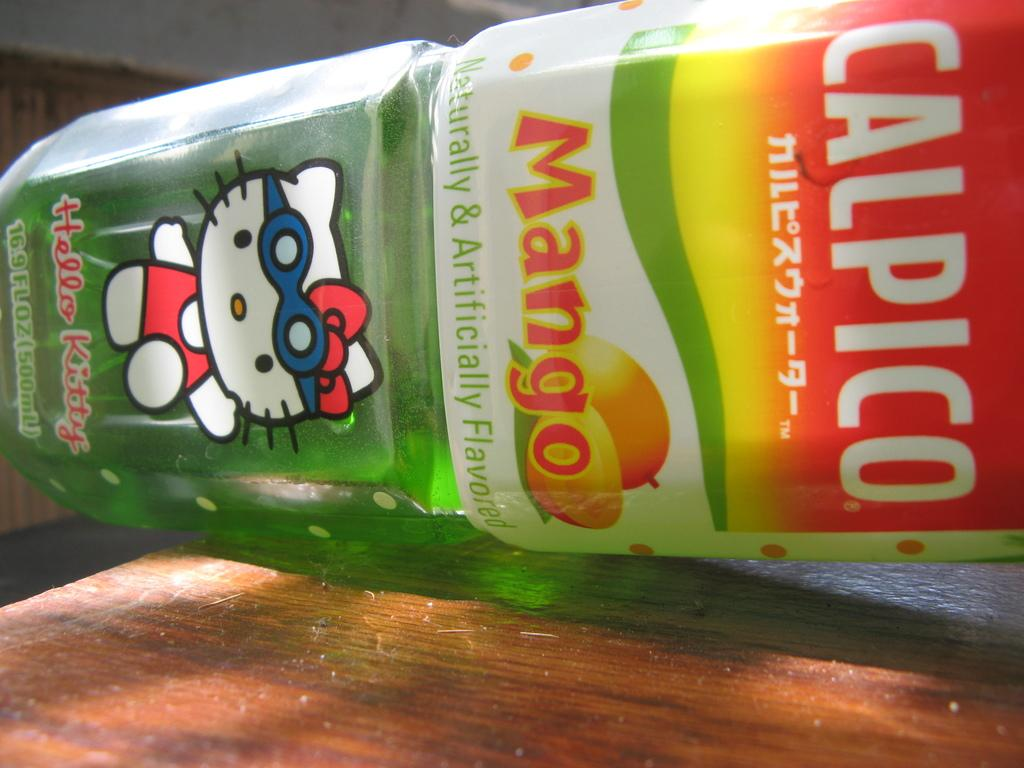<image>
Write a terse but informative summary of the picture. A bottle of Mango Calpico with a Hello Kitty picture on the bottom 